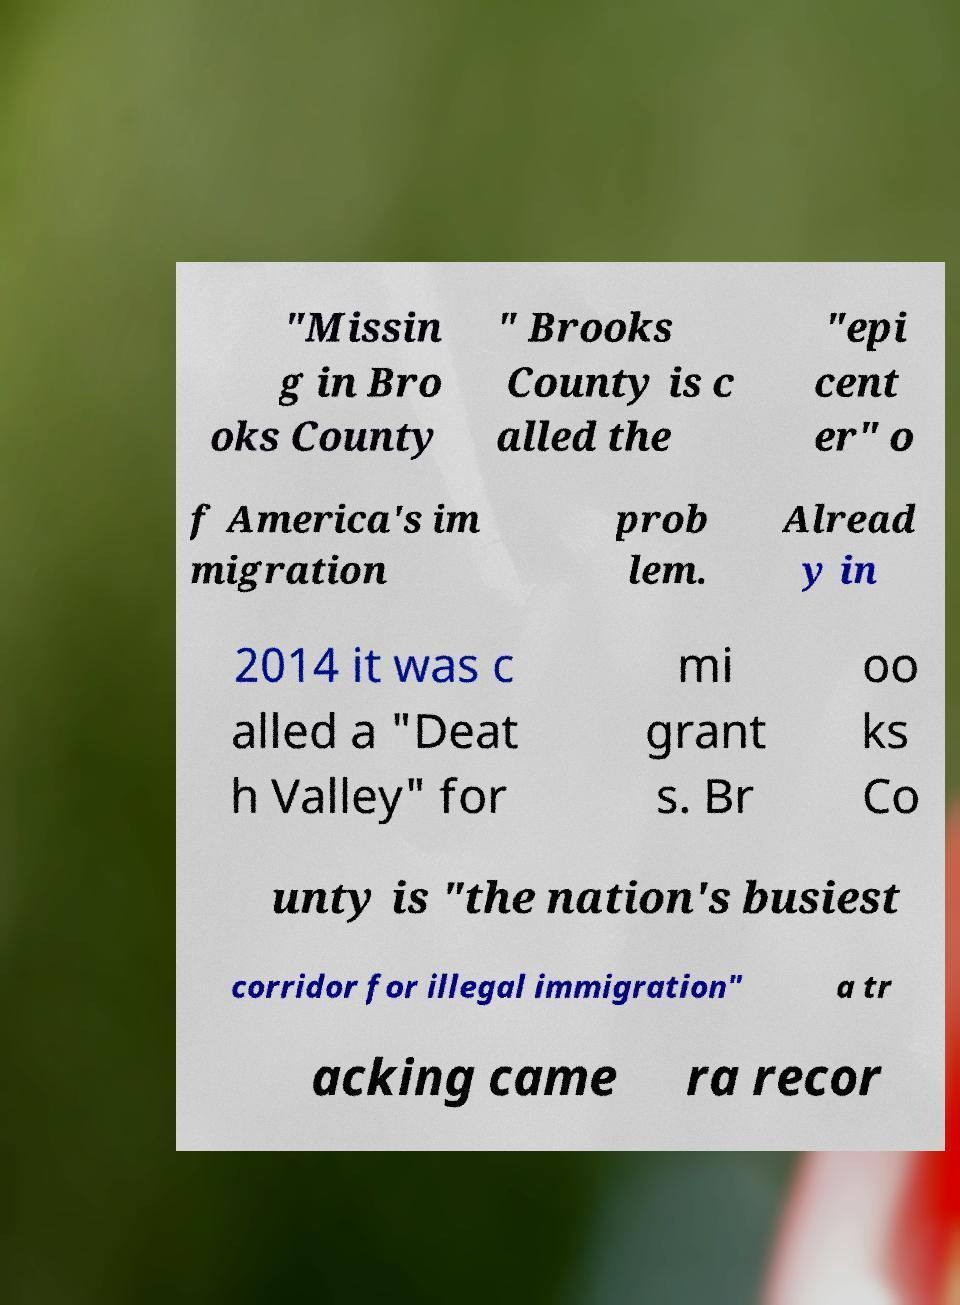There's text embedded in this image that I need extracted. Can you transcribe it verbatim? "Missin g in Bro oks County " Brooks County is c alled the "epi cent er" o f America's im migration prob lem. Alread y in 2014 it was c alled a "Deat h Valley" for mi grant s. Br oo ks Co unty is "the nation's busiest corridor for illegal immigration" a tr acking came ra recor 